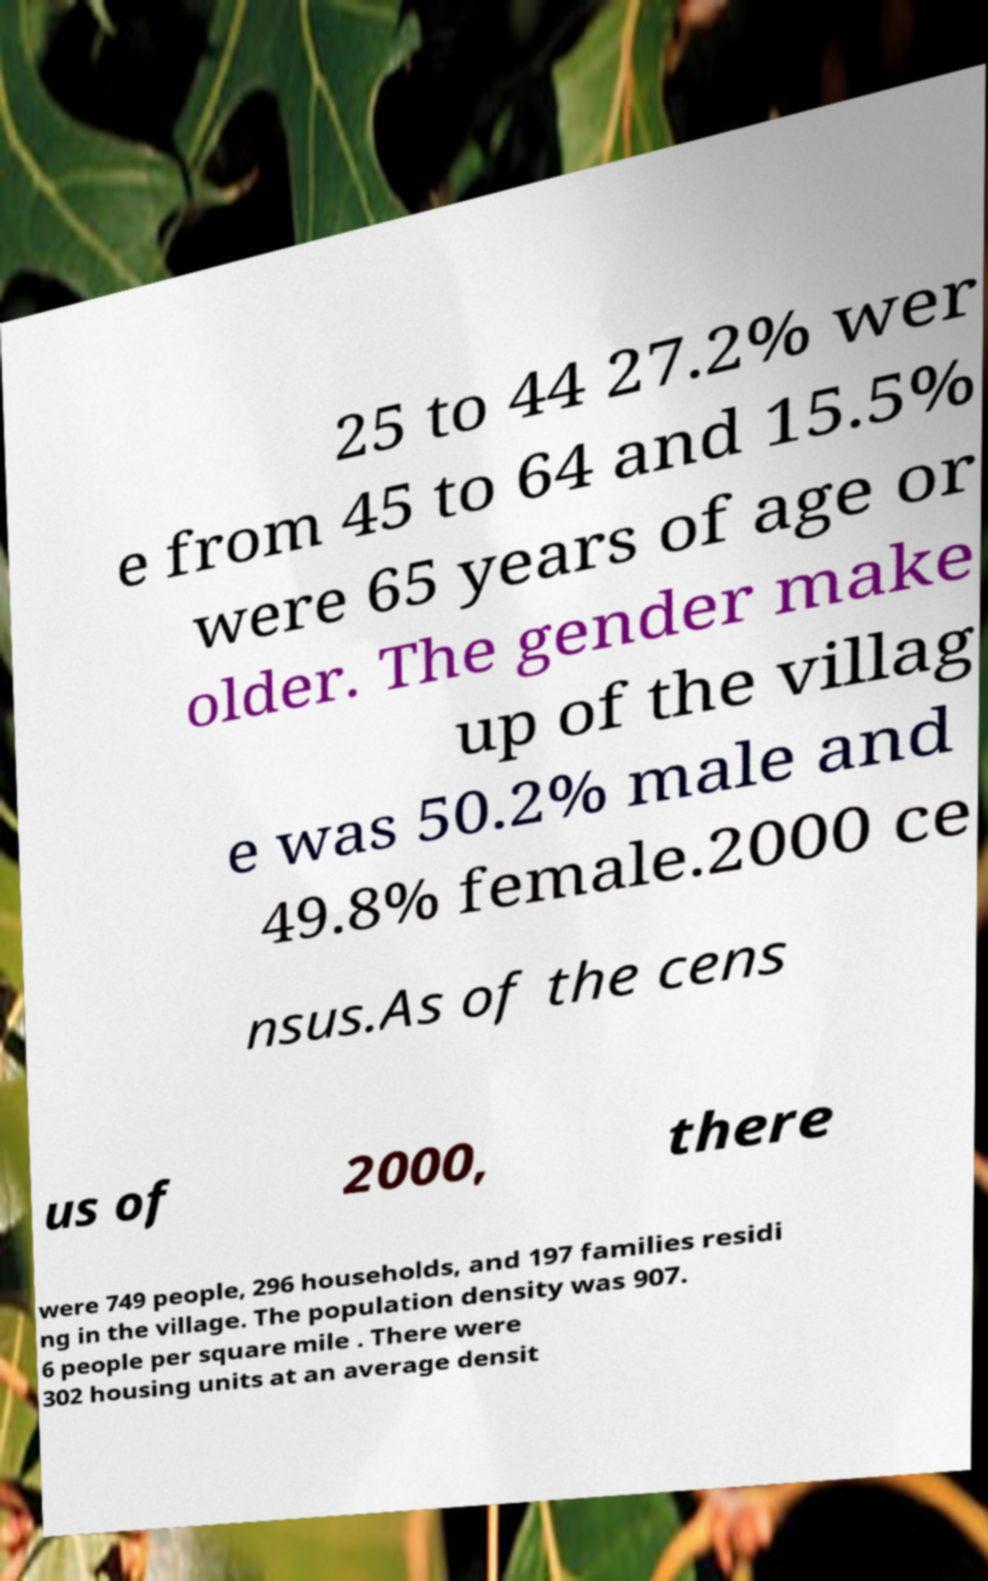Can you read and provide the text displayed in the image?This photo seems to have some interesting text. Can you extract and type it out for me? 25 to 44 27.2% wer e from 45 to 64 and 15.5% were 65 years of age or older. The gender make up of the villag e was 50.2% male and 49.8% female.2000 ce nsus.As of the cens us of 2000, there were 749 people, 296 households, and 197 families residi ng in the village. The population density was 907. 6 people per square mile . There were 302 housing units at an average densit 